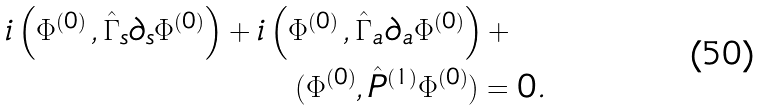Convert formula to latex. <formula><loc_0><loc_0><loc_500><loc_500>i \left ( { \Phi } ^ { ( 0 ) } \, , \hat { \Gamma } _ { s } \partial _ { s } { \Phi } ^ { ( 0 ) } \right ) + i \left ( { \Phi } ^ { ( 0 ) } \, , \hat { \Gamma } _ { a } \partial _ { a } { \Phi } ^ { ( 0 ) } \right ) + \quad \\ ( { \Phi } ^ { ( 0 ) } , \hat { P } ^ { ( 1 ) } { \Phi } ^ { ( 0 ) } ) = 0 .</formula> 